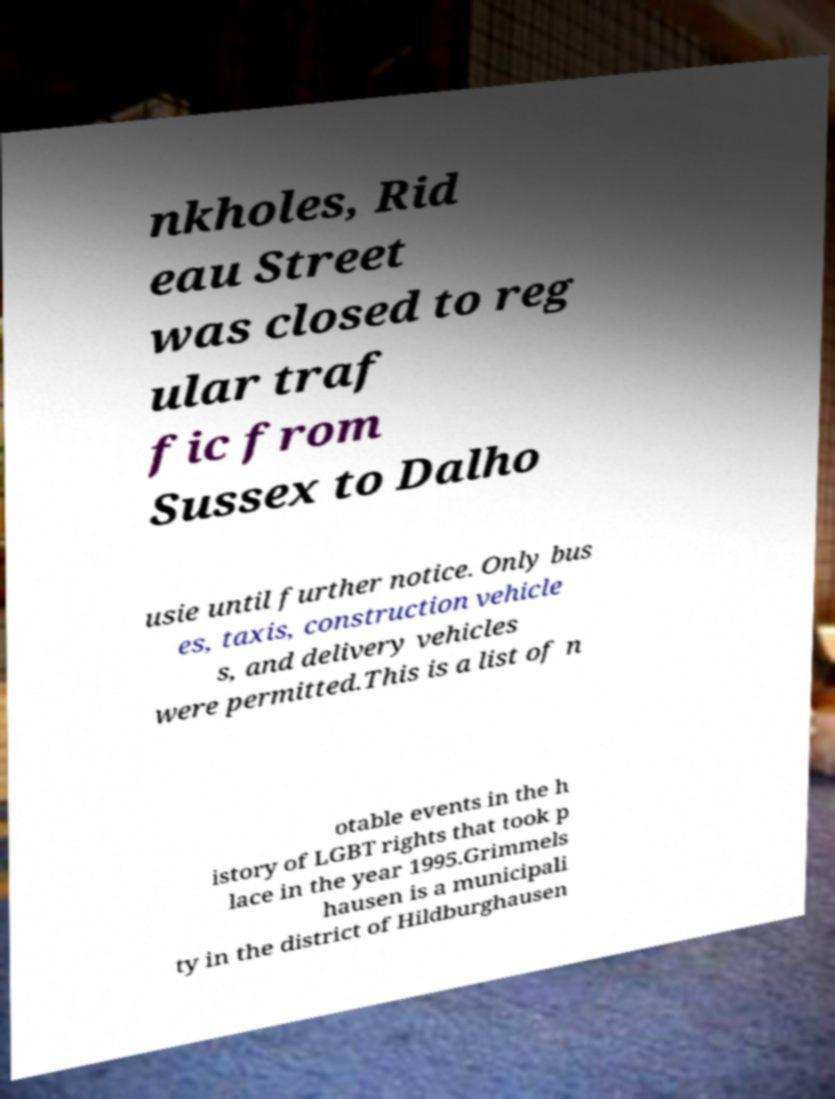I need the written content from this picture converted into text. Can you do that? nkholes, Rid eau Street was closed to reg ular traf fic from Sussex to Dalho usie until further notice. Only bus es, taxis, construction vehicle s, and delivery vehicles were permitted.This is a list of n otable events in the h istory of LGBT rights that took p lace in the year 1995.Grimmels hausen is a municipali ty in the district of Hildburghausen 